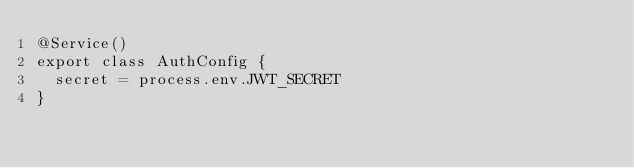<code> <loc_0><loc_0><loc_500><loc_500><_TypeScript_>@Service()
export class AuthConfig {
  secret = process.env.JWT_SECRET
}
</code> 